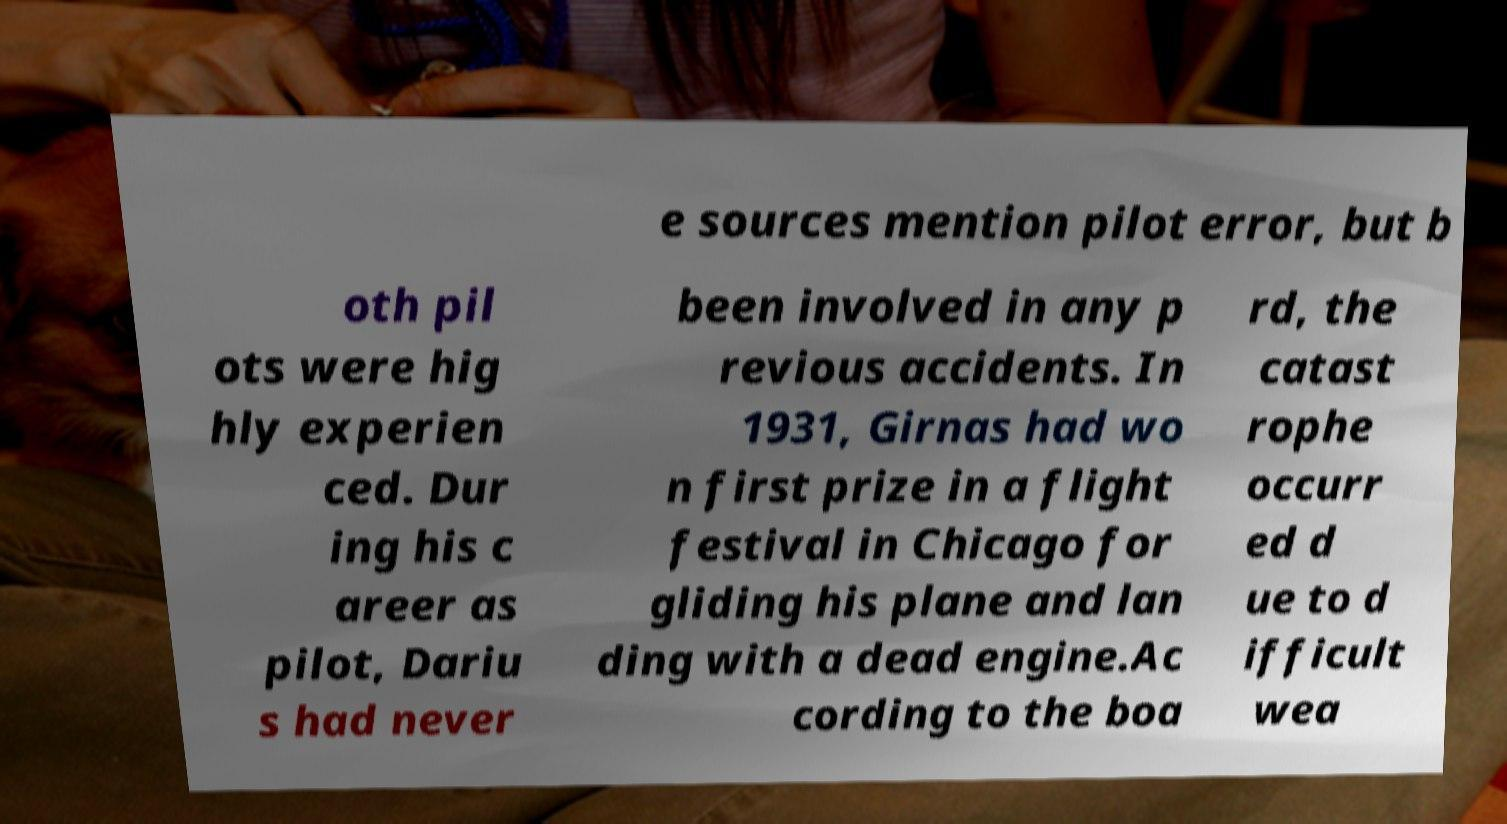Please read and relay the text visible in this image. What does it say? e sources mention pilot error, but b oth pil ots were hig hly experien ced. Dur ing his c areer as pilot, Dariu s had never been involved in any p revious accidents. In 1931, Girnas had wo n first prize in a flight festival in Chicago for gliding his plane and lan ding with a dead engine.Ac cording to the boa rd, the catast rophe occurr ed d ue to d ifficult wea 